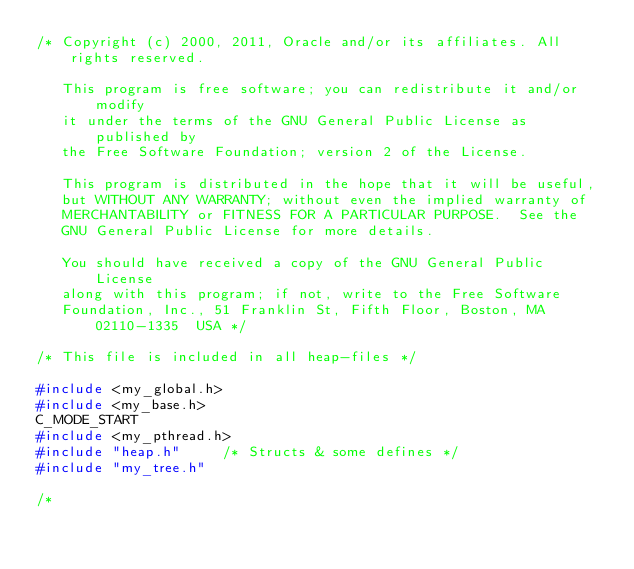<code> <loc_0><loc_0><loc_500><loc_500><_C_>/* Copyright (c) 2000, 2011, Oracle and/or its affiliates. All rights reserved.

   This program is free software; you can redistribute it and/or modify
   it under the terms of the GNU General Public License as published by
   the Free Software Foundation; version 2 of the License.

   This program is distributed in the hope that it will be useful,
   but WITHOUT ANY WARRANTY; without even the implied warranty of
   MERCHANTABILITY or FITNESS FOR A PARTICULAR PURPOSE.  See the
   GNU General Public License for more details.

   You should have received a copy of the GNU General Public License
   along with this program; if not, write to the Free Software
   Foundation, Inc., 51 Franklin St, Fifth Floor, Boston, MA 02110-1335  USA */

/* This file is included in all heap-files */

#include <my_global.h>
#include <my_base.h>
C_MODE_START
#include <my_pthread.h>
#include "heap.h"			/* Structs & some defines */
#include "my_tree.h"

/*</code> 